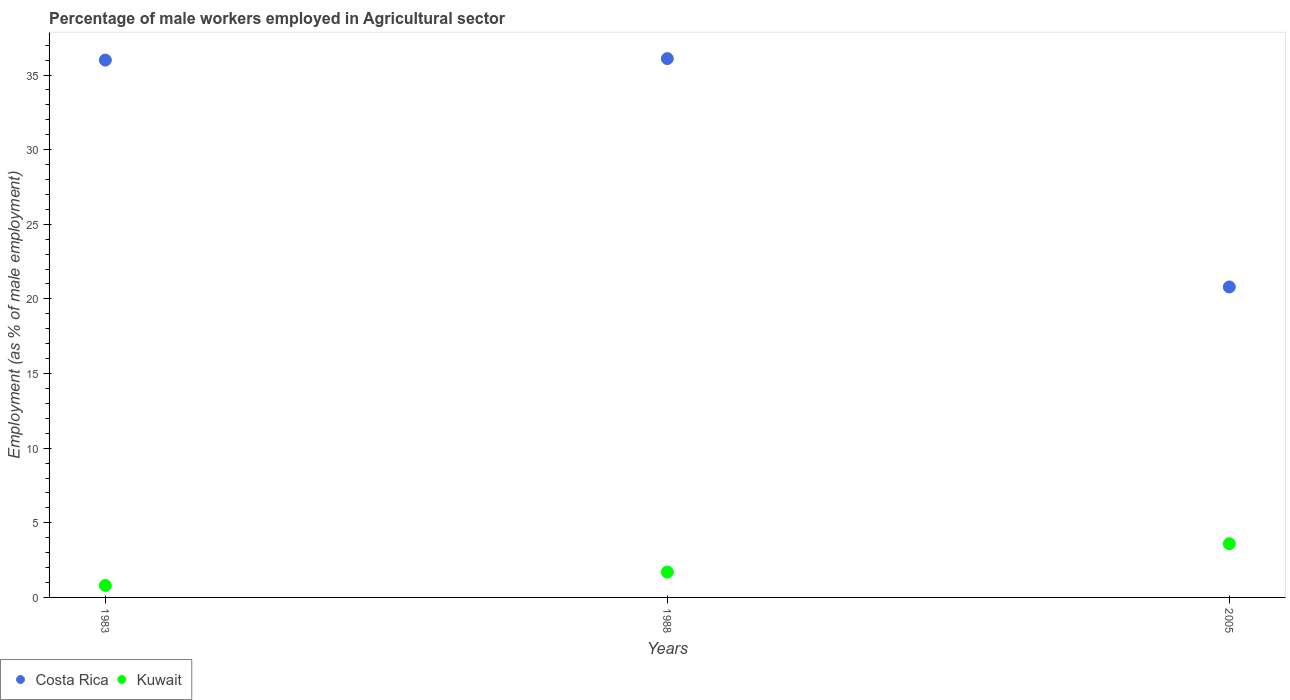How many different coloured dotlines are there?
Offer a very short reply. 2. Is the number of dotlines equal to the number of legend labels?
Your response must be concise. Yes. What is the percentage of male workers employed in Agricultural sector in Costa Rica in 1983?
Offer a very short reply. 36. Across all years, what is the maximum percentage of male workers employed in Agricultural sector in Kuwait?
Your answer should be very brief. 3.6. Across all years, what is the minimum percentage of male workers employed in Agricultural sector in Kuwait?
Provide a succinct answer. 0.8. In which year was the percentage of male workers employed in Agricultural sector in Costa Rica maximum?
Keep it short and to the point. 1988. What is the total percentage of male workers employed in Agricultural sector in Costa Rica in the graph?
Give a very brief answer. 92.9. What is the difference between the percentage of male workers employed in Agricultural sector in Kuwait in 1983 and that in 2005?
Give a very brief answer. -2.8. What is the difference between the percentage of male workers employed in Agricultural sector in Costa Rica in 1983 and the percentage of male workers employed in Agricultural sector in Kuwait in 2005?
Give a very brief answer. 32.4. What is the average percentage of male workers employed in Agricultural sector in Costa Rica per year?
Provide a short and direct response. 30.97. In the year 2005, what is the difference between the percentage of male workers employed in Agricultural sector in Costa Rica and percentage of male workers employed in Agricultural sector in Kuwait?
Your response must be concise. 17.2. What is the ratio of the percentage of male workers employed in Agricultural sector in Costa Rica in 1988 to that in 2005?
Provide a short and direct response. 1.74. Is the percentage of male workers employed in Agricultural sector in Kuwait in 1983 less than that in 1988?
Offer a very short reply. Yes. What is the difference between the highest and the second highest percentage of male workers employed in Agricultural sector in Costa Rica?
Ensure brevity in your answer.  0.1. What is the difference between the highest and the lowest percentage of male workers employed in Agricultural sector in Kuwait?
Provide a short and direct response. 2.8. Is the percentage of male workers employed in Agricultural sector in Kuwait strictly less than the percentage of male workers employed in Agricultural sector in Costa Rica over the years?
Offer a very short reply. Yes. Are the values on the major ticks of Y-axis written in scientific E-notation?
Provide a succinct answer. No. Does the graph contain any zero values?
Your response must be concise. No. Where does the legend appear in the graph?
Your answer should be compact. Bottom left. How many legend labels are there?
Offer a very short reply. 2. What is the title of the graph?
Your response must be concise. Percentage of male workers employed in Agricultural sector. What is the label or title of the Y-axis?
Your answer should be compact. Employment (as % of male employment). What is the Employment (as % of male employment) of Costa Rica in 1983?
Your response must be concise. 36. What is the Employment (as % of male employment) in Kuwait in 1983?
Make the answer very short. 0.8. What is the Employment (as % of male employment) of Costa Rica in 1988?
Keep it short and to the point. 36.1. What is the Employment (as % of male employment) in Kuwait in 1988?
Provide a short and direct response. 1.7. What is the Employment (as % of male employment) in Costa Rica in 2005?
Your response must be concise. 20.8. What is the Employment (as % of male employment) in Kuwait in 2005?
Offer a terse response. 3.6. Across all years, what is the maximum Employment (as % of male employment) in Costa Rica?
Make the answer very short. 36.1. Across all years, what is the maximum Employment (as % of male employment) of Kuwait?
Offer a terse response. 3.6. Across all years, what is the minimum Employment (as % of male employment) in Costa Rica?
Ensure brevity in your answer.  20.8. Across all years, what is the minimum Employment (as % of male employment) of Kuwait?
Ensure brevity in your answer.  0.8. What is the total Employment (as % of male employment) in Costa Rica in the graph?
Keep it short and to the point. 92.9. What is the difference between the Employment (as % of male employment) in Costa Rica in 1983 and that in 1988?
Provide a succinct answer. -0.1. What is the difference between the Employment (as % of male employment) in Costa Rica in 1983 and that in 2005?
Provide a short and direct response. 15.2. What is the difference between the Employment (as % of male employment) in Kuwait in 1983 and that in 2005?
Offer a very short reply. -2.8. What is the difference between the Employment (as % of male employment) of Costa Rica in 1988 and that in 2005?
Ensure brevity in your answer.  15.3. What is the difference between the Employment (as % of male employment) of Costa Rica in 1983 and the Employment (as % of male employment) of Kuwait in 1988?
Offer a very short reply. 34.3. What is the difference between the Employment (as % of male employment) of Costa Rica in 1983 and the Employment (as % of male employment) of Kuwait in 2005?
Keep it short and to the point. 32.4. What is the difference between the Employment (as % of male employment) of Costa Rica in 1988 and the Employment (as % of male employment) of Kuwait in 2005?
Provide a succinct answer. 32.5. What is the average Employment (as % of male employment) in Costa Rica per year?
Make the answer very short. 30.97. What is the average Employment (as % of male employment) in Kuwait per year?
Make the answer very short. 2.03. In the year 1983, what is the difference between the Employment (as % of male employment) of Costa Rica and Employment (as % of male employment) of Kuwait?
Provide a short and direct response. 35.2. In the year 1988, what is the difference between the Employment (as % of male employment) in Costa Rica and Employment (as % of male employment) in Kuwait?
Provide a short and direct response. 34.4. What is the ratio of the Employment (as % of male employment) of Kuwait in 1983 to that in 1988?
Your answer should be very brief. 0.47. What is the ratio of the Employment (as % of male employment) of Costa Rica in 1983 to that in 2005?
Ensure brevity in your answer.  1.73. What is the ratio of the Employment (as % of male employment) in Kuwait in 1983 to that in 2005?
Keep it short and to the point. 0.22. What is the ratio of the Employment (as % of male employment) of Costa Rica in 1988 to that in 2005?
Provide a short and direct response. 1.74. What is the ratio of the Employment (as % of male employment) in Kuwait in 1988 to that in 2005?
Your answer should be compact. 0.47. What is the difference between the highest and the lowest Employment (as % of male employment) of Costa Rica?
Keep it short and to the point. 15.3. 